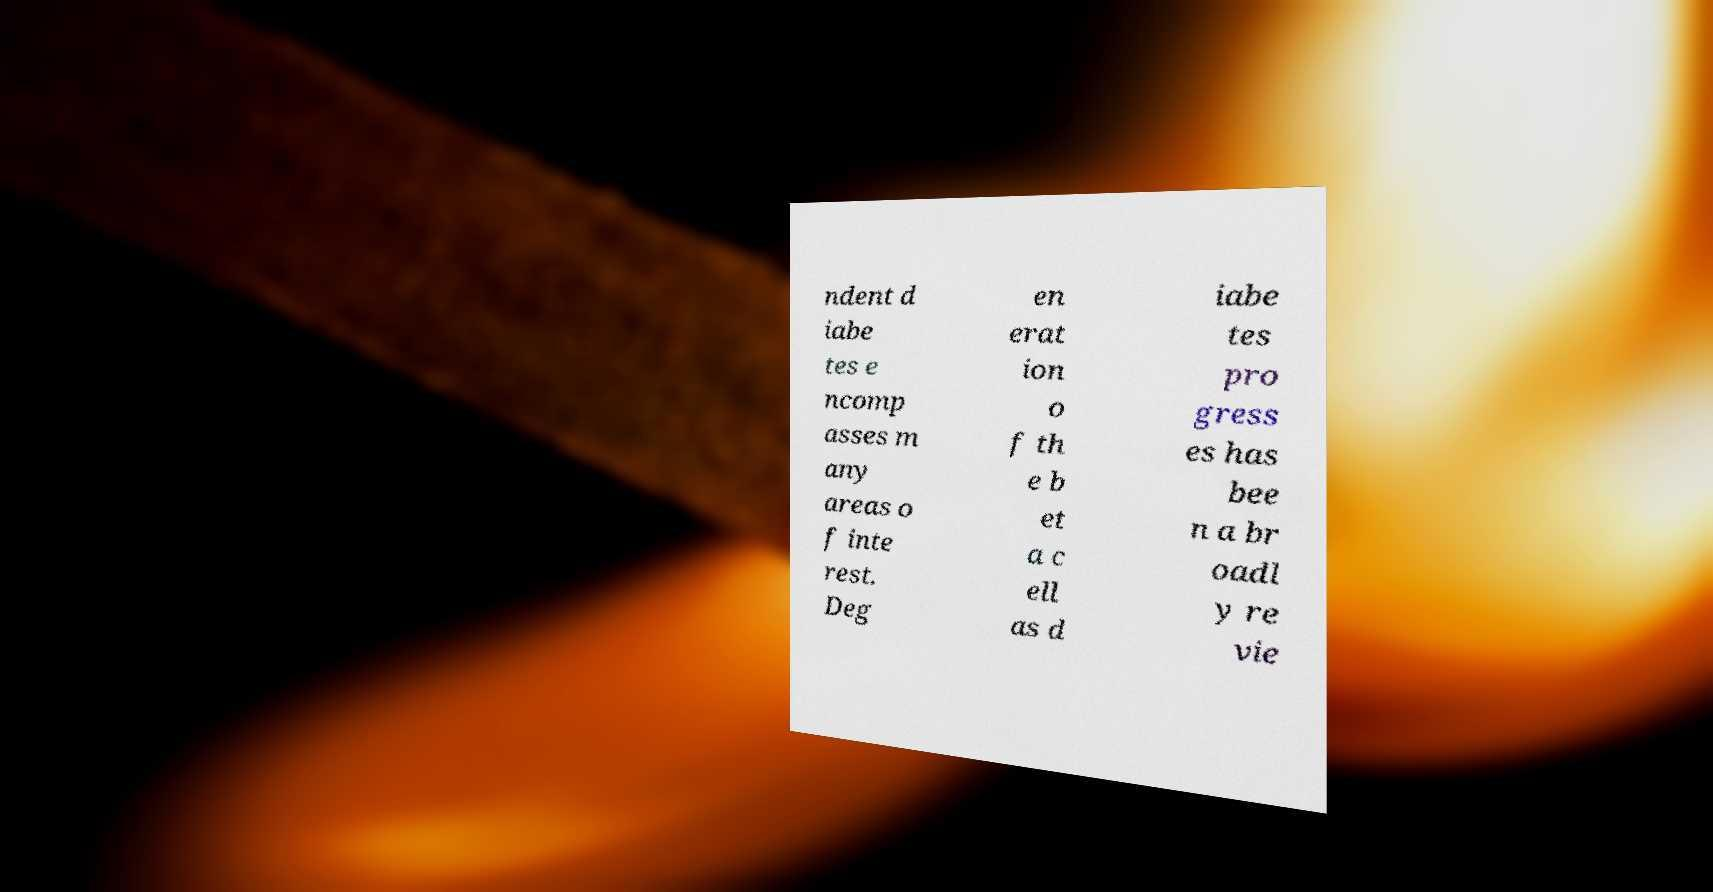Could you extract and type out the text from this image? ndent d iabe tes e ncomp asses m any areas o f inte rest. Deg en erat ion o f th e b et a c ell as d iabe tes pro gress es has bee n a br oadl y re vie 